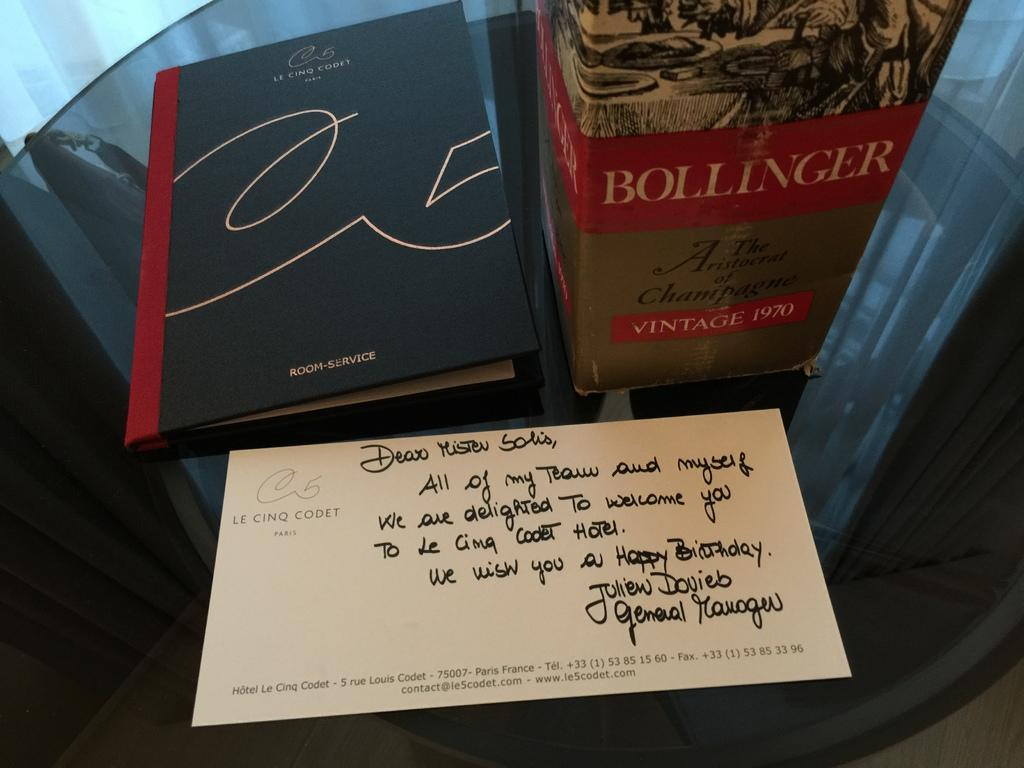What type of object can be seen in the image? There is a book in the image. What other item is present in the image? There is paper in the image. Is there any container visible in the image? Yes, there is a box in the image. On what surface are the objects placed? The objects are on a glass surface. What type of sweater is being worn by the book in the image? There is no sweater present in the image, as the main subject is a book and not a person or living being. 